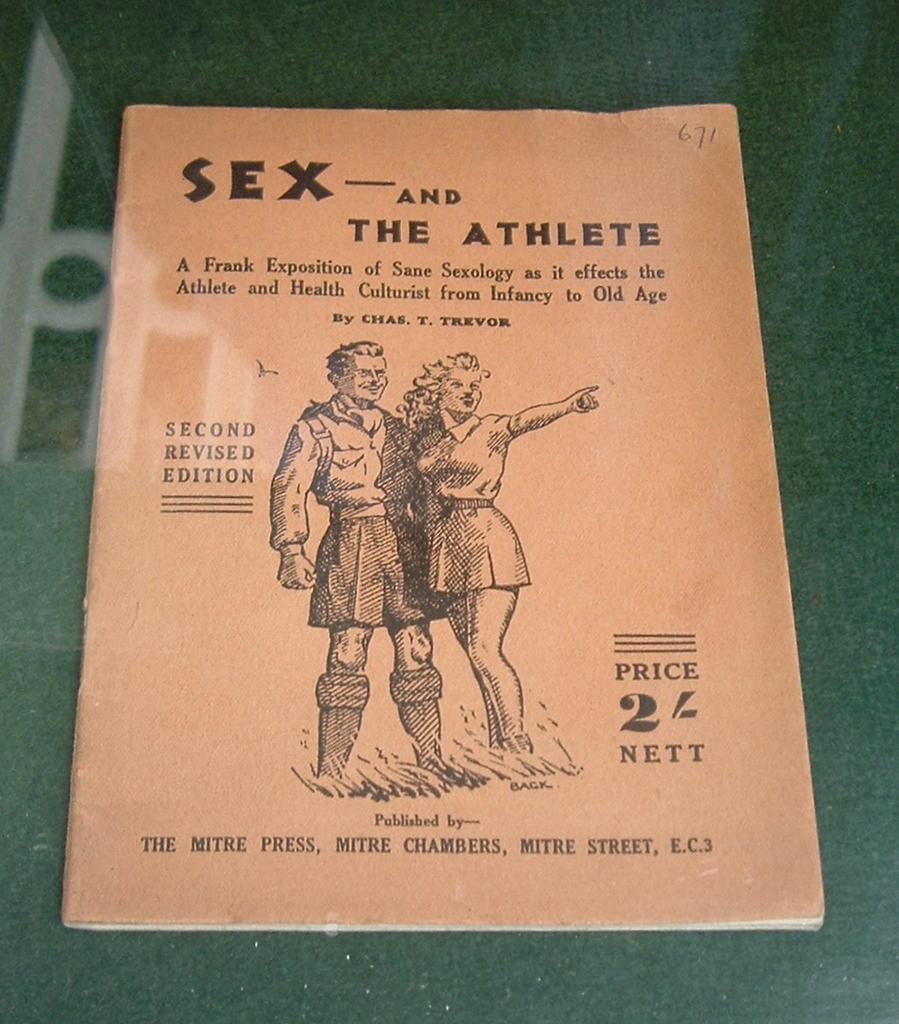In one or two sentences, can you explain what this image depicts? In this image we can see a book on the green colored surface, there are some text, images on the cover page of the book. 